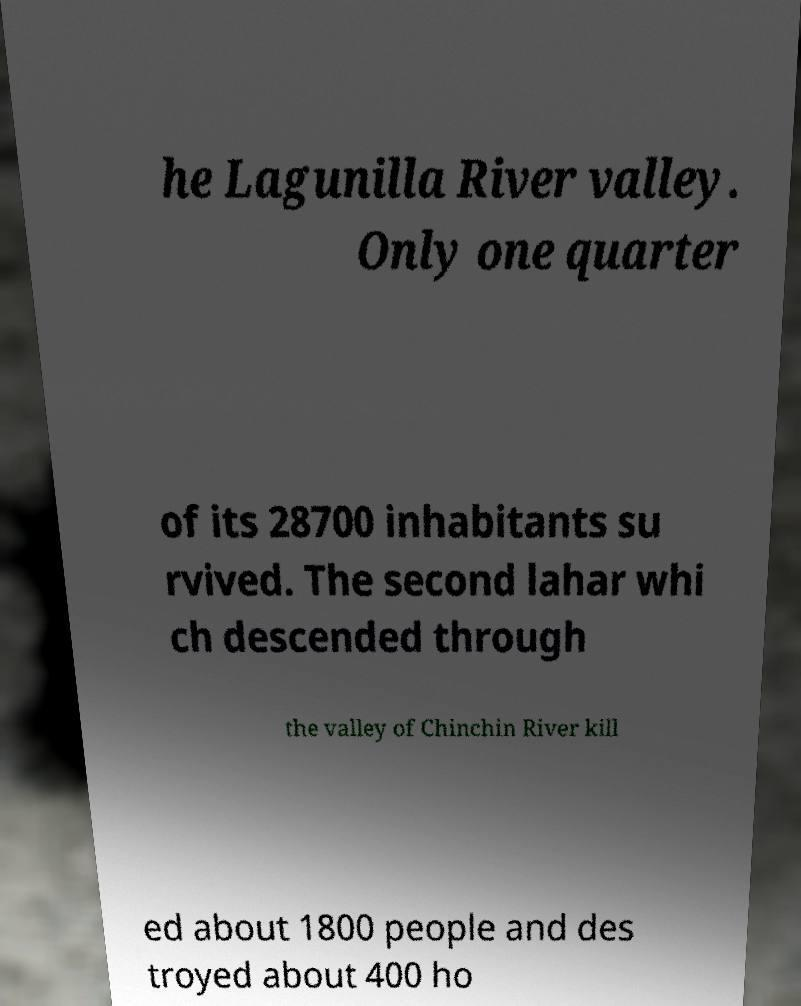Could you extract and type out the text from this image? he Lagunilla River valley. Only one quarter of its 28700 inhabitants su rvived. The second lahar whi ch descended through the valley of Chinchin River kill ed about 1800 people and des troyed about 400 ho 